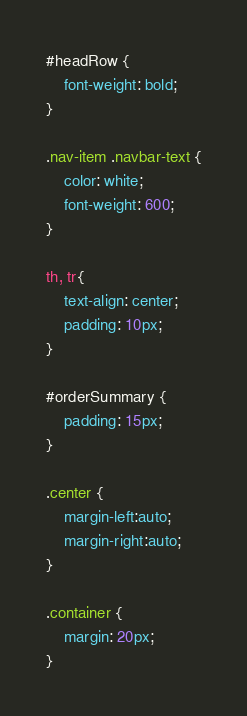<code> <loc_0><loc_0><loc_500><loc_500><_CSS_>#headRow {
    font-weight: bold;
}

.nav-item .navbar-text {
    color: white;
    font-weight: 600;
}

th, tr{
    text-align: center;
    padding: 10px;
}

#orderSummary {
    padding: 15px;
}

.center {
    margin-left:auto; 
    margin-right:auto;
}

.container {
    margin: 20px;
}</code> 